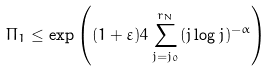<formula> <loc_0><loc_0><loc_500><loc_500>\Pi _ { 1 } \leq \exp \left ( ( 1 + \varepsilon ) 4 \sum _ { j = j _ { 0 } } ^ { r _ { N } } ( j \log j ) ^ { - \alpha } \right )</formula> 